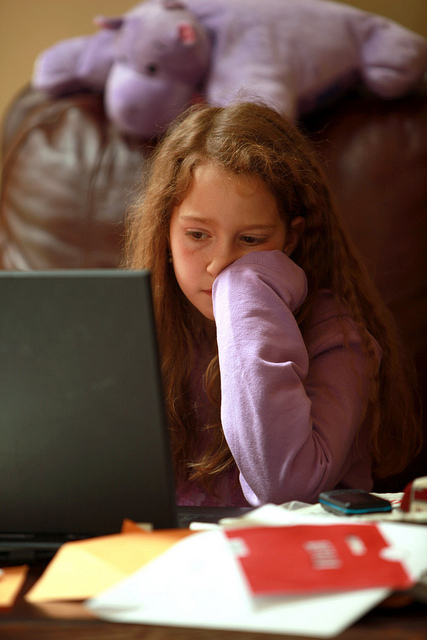<image>Who is the author of the book? There is no book in the image to determine the author. Who is the author of the book? It is unknown who is the author of the book. There is no book to see. 